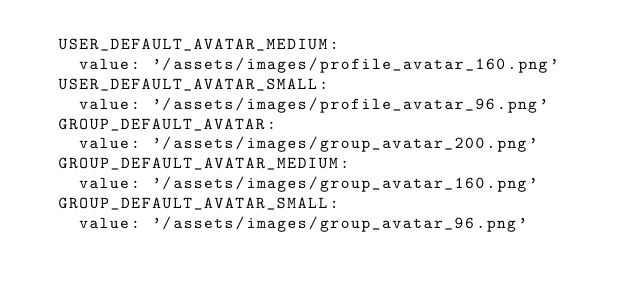<code> <loc_0><loc_0><loc_500><loc_500><_YAML_>  USER_DEFAULT_AVATAR_MEDIUM:
    value: '/assets/images/profile_avatar_160.png'
  USER_DEFAULT_AVATAR_SMALL:
    value: '/assets/images/profile_avatar_96.png'
  GROUP_DEFAULT_AVATAR:
    value: '/assets/images/group_avatar_200.png'
  GROUP_DEFAULT_AVATAR_MEDIUM:
    value: '/assets/images/group_avatar_160.png'
  GROUP_DEFAULT_AVATAR_SMALL:
    value: '/assets/images/group_avatar_96.png'
</code> 